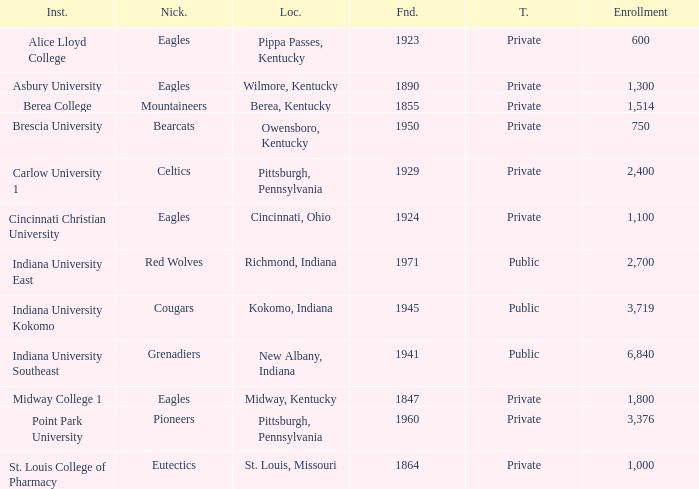Which public college has a nickname of The Grenadiers? Indiana University Southeast. 